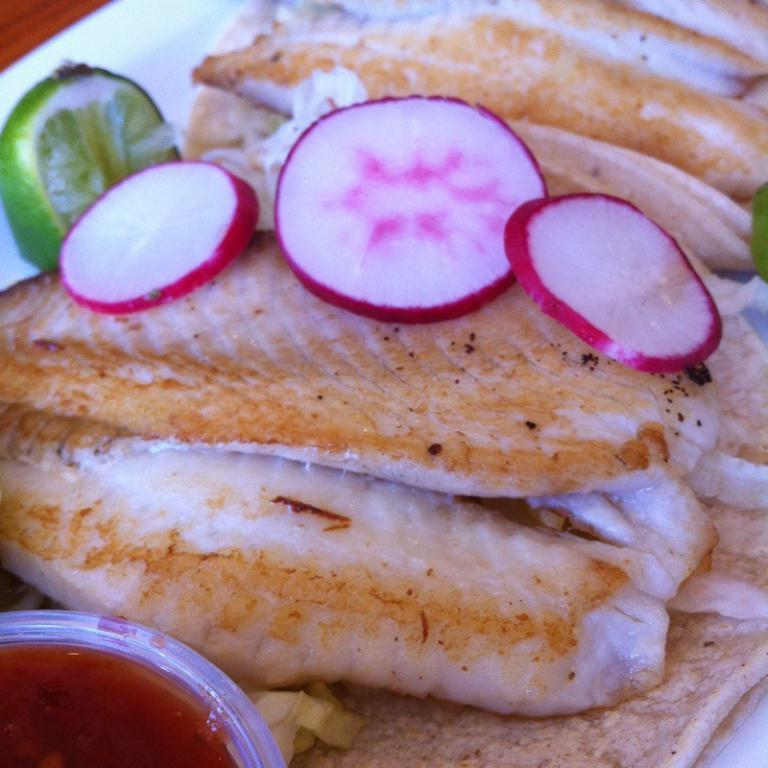What is on the plate that is visible in the image? The plate contains meat and other food items. What else can be seen in the image besides the plate? There is a bowl at the bottom of the image. What type of cattle can be seen grazing in the image? There is no cattle present in the image; it only contains a plate with food items and a bowl. What shape is the selection of food on the plate? The provided facts do not mention the shape of the food on the plate, so we cannot answer this question definitively. 